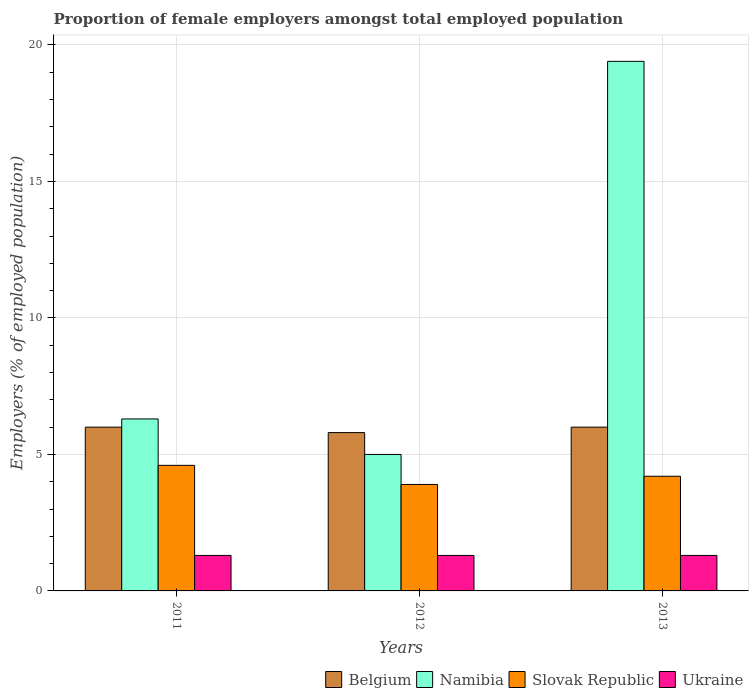How many different coloured bars are there?
Your answer should be very brief. 4. How many groups of bars are there?
Offer a terse response. 3. Are the number of bars per tick equal to the number of legend labels?
Make the answer very short. Yes. Are the number of bars on each tick of the X-axis equal?
Give a very brief answer. Yes. How many bars are there on the 2nd tick from the left?
Give a very brief answer. 4. What is the label of the 1st group of bars from the left?
Ensure brevity in your answer.  2011. In how many cases, is the number of bars for a given year not equal to the number of legend labels?
Ensure brevity in your answer.  0. Across all years, what is the maximum proportion of female employers in Belgium?
Your response must be concise. 6. Across all years, what is the minimum proportion of female employers in Belgium?
Keep it short and to the point. 5.8. What is the total proportion of female employers in Belgium in the graph?
Your answer should be very brief. 17.8. What is the difference between the proportion of female employers in Slovak Republic in 2012 and that in 2013?
Keep it short and to the point. -0.3. What is the difference between the proportion of female employers in Namibia in 2012 and the proportion of female employers in Slovak Republic in 2013?
Provide a short and direct response. 0.8. What is the average proportion of female employers in Ukraine per year?
Provide a succinct answer. 1.3. In the year 2013, what is the difference between the proportion of female employers in Slovak Republic and proportion of female employers in Ukraine?
Make the answer very short. 2.9. In how many years, is the proportion of female employers in Namibia greater than 16 %?
Your response must be concise. 1. What is the ratio of the proportion of female employers in Belgium in 2012 to that in 2013?
Your answer should be compact. 0.97. Is the proportion of female employers in Slovak Republic in 2011 less than that in 2012?
Ensure brevity in your answer.  No. Is the difference between the proportion of female employers in Slovak Republic in 2011 and 2012 greater than the difference between the proportion of female employers in Ukraine in 2011 and 2012?
Offer a very short reply. Yes. What is the difference between the highest and the lowest proportion of female employers in Ukraine?
Your answer should be very brief. 0. What does the 4th bar from the left in 2012 represents?
Your answer should be compact. Ukraine. What does the 2nd bar from the right in 2011 represents?
Give a very brief answer. Slovak Republic. How many bars are there?
Offer a very short reply. 12. Are all the bars in the graph horizontal?
Keep it short and to the point. No. How many years are there in the graph?
Offer a very short reply. 3. What is the difference between two consecutive major ticks on the Y-axis?
Provide a short and direct response. 5. Are the values on the major ticks of Y-axis written in scientific E-notation?
Keep it short and to the point. No. Does the graph contain grids?
Provide a succinct answer. Yes. How many legend labels are there?
Keep it short and to the point. 4. How are the legend labels stacked?
Offer a very short reply. Horizontal. What is the title of the graph?
Your answer should be compact. Proportion of female employers amongst total employed population. Does "Norway" appear as one of the legend labels in the graph?
Your answer should be very brief. No. What is the label or title of the Y-axis?
Offer a very short reply. Employers (% of employed population). What is the Employers (% of employed population) of Namibia in 2011?
Your answer should be compact. 6.3. What is the Employers (% of employed population) in Slovak Republic in 2011?
Provide a succinct answer. 4.6. What is the Employers (% of employed population) of Ukraine in 2011?
Give a very brief answer. 1.3. What is the Employers (% of employed population) in Belgium in 2012?
Provide a short and direct response. 5.8. What is the Employers (% of employed population) of Namibia in 2012?
Give a very brief answer. 5. What is the Employers (% of employed population) of Slovak Republic in 2012?
Provide a succinct answer. 3.9. What is the Employers (% of employed population) of Ukraine in 2012?
Your answer should be compact. 1.3. What is the Employers (% of employed population) in Namibia in 2013?
Your response must be concise. 19.4. What is the Employers (% of employed population) in Slovak Republic in 2013?
Provide a short and direct response. 4.2. What is the Employers (% of employed population) in Ukraine in 2013?
Your answer should be very brief. 1.3. Across all years, what is the maximum Employers (% of employed population) of Belgium?
Your answer should be compact. 6. Across all years, what is the maximum Employers (% of employed population) in Namibia?
Keep it short and to the point. 19.4. Across all years, what is the maximum Employers (% of employed population) of Slovak Republic?
Offer a very short reply. 4.6. Across all years, what is the maximum Employers (% of employed population) of Ukraine?
Make the answer very short. 1.3. Across all years, what is the minimum Employers (% of employed population) in Belgium?
Give a very brief answer. 5.8. Across all years, what is the minimum Employers (% of employed population) in Slovak Republic?
Offer a terse response. 3.9. Across all years, what is the minimum Employers (% of employed population) in Ukraine?
Your response must be concise. 1.3. What is the total Employers (% of employed population) in Belgium in the graph?
Your answer should be compact. 17.8. What is the total Employers (% of employed population) of Namibia in the graph?
Make the answer very short. 30.7. What is the total Employers (% of employed population) of Slovak Republic in the graph?
Provide a succinct answer. 12.7. What is the total Employers (% of employed population) of Ukraine in the graph?
Make the answer very short. 3.9. What is the difference between the Employers (% of employed population) of Belgium in 2011 and that in 2012?
Provide a short and direct response. 0.2. What is the difference between the Employers (% of employed population) in Namibia in 2011 and that in 2012?
Provide a short and direct response. 1.3. What is the difference between the Employers (% of employed population) in Belgium in 2011 and that in 2013?
Provide a short and direct response. 0. What is the difference between the Employers (% of employed population) of Namibia in 2011 and that in 2013?
Keep it short and to the point. -13.1. What is the difference between the Employers (% of employed population) in Belgium in 2012 and that in 2013?
Keep it short and to the point. -0.2. What is the difference between the Employers (% of employed population) in Namibia in 2012 and that in 2013?
Ensure brevity in your answer.  -14.4. What is the difference between the Employers (% of employed population) of Slovak Republic in 2012 and that in 2013?
Ensure brevity in your answer.  -0.3. What is the difference between the Employers (% of employed population) of Ukraine in 2012 and that in 2013?
Your response must be concise. 0. What is the difference between the Employers (% of employed population) in Namibia in 2011 and the Employers (% of employed population) in Ukraine in 2012?
Provide a short and direct response. 5. What is the difference between the Employers (% of employed population) in Slovak Republic in 2011 and the Employers (% of employed population) in Ukraine in 2012?
Provide a succinct answer. 3.3. What is the difference between the Employers (% of employed population) in Belgium in 2012 and the Employers (% of employed population) in Namibia in 2013?
Your answer should be compact. -13.6. What is the difference between the Employers (% of employed population) of Belgium in 2012 and the Employers (% of employed population) of Slovak Republic in 2013?
Make the answer very short. 1.6. What is the difference between the Employers (% of employed population) of Namibia in 2012 and the Employers (% of employed population) of Slovak Republic in 2013?
Your answer should be very brief. 0.8. What is the difference between the Employers (% of employed population) in Slovak Republic in 2012 and the Employers (% of employed population) in Ukraine in 2013?
Make the answer very short. 2.6. What is the average Employers (% of employed population) in Belgium per year?
Your answer should be compact. 5.93. What is the average Employers (% of employed population) in Namibia per year?
Give a very brief answer. 10.23. What is the average Employers (% of employed population) of Slovak Republic per year?
Your answer should be compact. 4.23. What is the average Employers (% of employed population) of Ukraine per year?
Provide a succinct answer. 1.3. In the year 2011, what is the difference between the Employers (% of employed population) in Belgium and Employers (% of employed population) in Namibia?
Your answer should be very brief. -0.3. In the year 2011, what is the difference between the Employers (% of employed population) of Belgium and Employers (% of employed population) of Ukraine?
Ensure brevity in your answer.  4.7. In the year 2012, what is the difference between the Employers (% of employed population) in Belgium and Employers (% of employed population) in Namibia?
Give a very brief answer. 0.8. In the year 2012, what is the difference between the Employers (% of employed population) of Belgium and Employers (% of employed population) of Slovak Republic?
Give a very brief answer. 1.9. In the year 2012, what is the difference between the Employers (% of employed population) in Belgium and Employers (% of employed population) in Ukraine?
Keep it short and to the point. 4.5. In the year 2013, what is the difference between the Employers (% of employed population) in Belgium and Employers (% of employed population) in Namibia?
Ensure brevity in your answer.  -13.4. In the year 2013, what is the difference between the Employers (% of employed population) in Namibia and Employers (% of employed population) in Slovak Republic?
Your response must be concise. 15.2. What is the ratio of the Employers (% of employed population) in Belgium in 2011 to that in 2012?
Your answer should be very brief. 1.03. What is the ratio of the Employers (% of employed population) in Namibia in 2011 to that in 2012?
Keep it short and to the point. 1.26. What is the ratio of the Employers (% of employed population) of Slovak Republic in 2011 to that in 2012?
Give a very brief answer. 1.18. What is the ratio of the Employers (% of employed population) of Ukraine in 2011 to that in 2012?
Give a very brief answer. 1. What is the ratio of the Employers (% of employed population) in Namibia in 2011 to that in 2013?
Your answer should be compact. 0.32. What is the ratio of the Employers (% of employed population) of Slovak Republic in 2011 to that in 2013?
Your response must be concise. 1.1. What is the ratio of the Employers (% of employed population) of Ukraine in 2011 to that in 2013?
Provide a short and direct response. 1. What is the ratio of the Employers (% of employed population) in Belgium in 2012 to that in 2013?
Keep it short and to the point. 0.97. What is the ratio of the Employers (% of employed population) in Namibia in 2012 to that in 2013?
Your answer should be very brief. 0.26. What is the difference between the highest and the second highest Employers (% of employed population) of Namibia?
Ensure brevity in your answer.  13.1. What is the difference between the highest and the second highest Employers (% of employed population) of Slovak Republic?
Ensure brevity in your answer.  0.4. What is the difference between the highest and the lowest Employers (% of employed population) in Slovak Republic?
Ensure brevity in your answer.  0.7. 